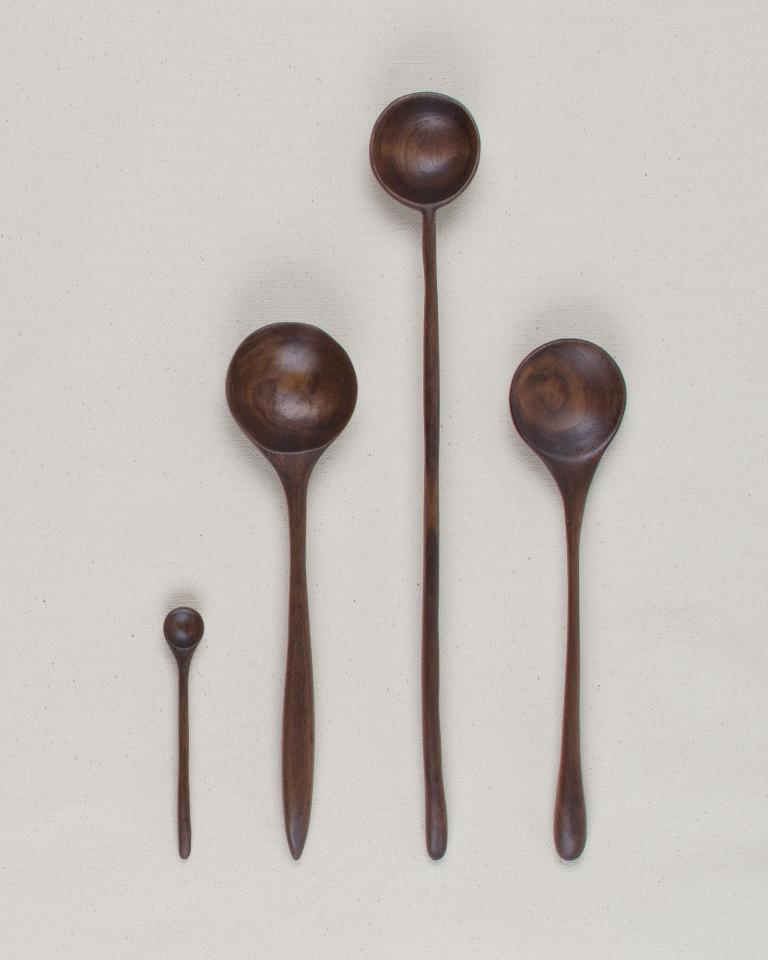What type of utensils are in the image? There is a wooden spatula set in the image. Where are the wooden spatulas located? The wooden spatula set is placed on a surface. Can you see any bees flying around the wooden spatula set in the image? There are no bees present in the image; it only features a wooden spatula set placed on a surface. 